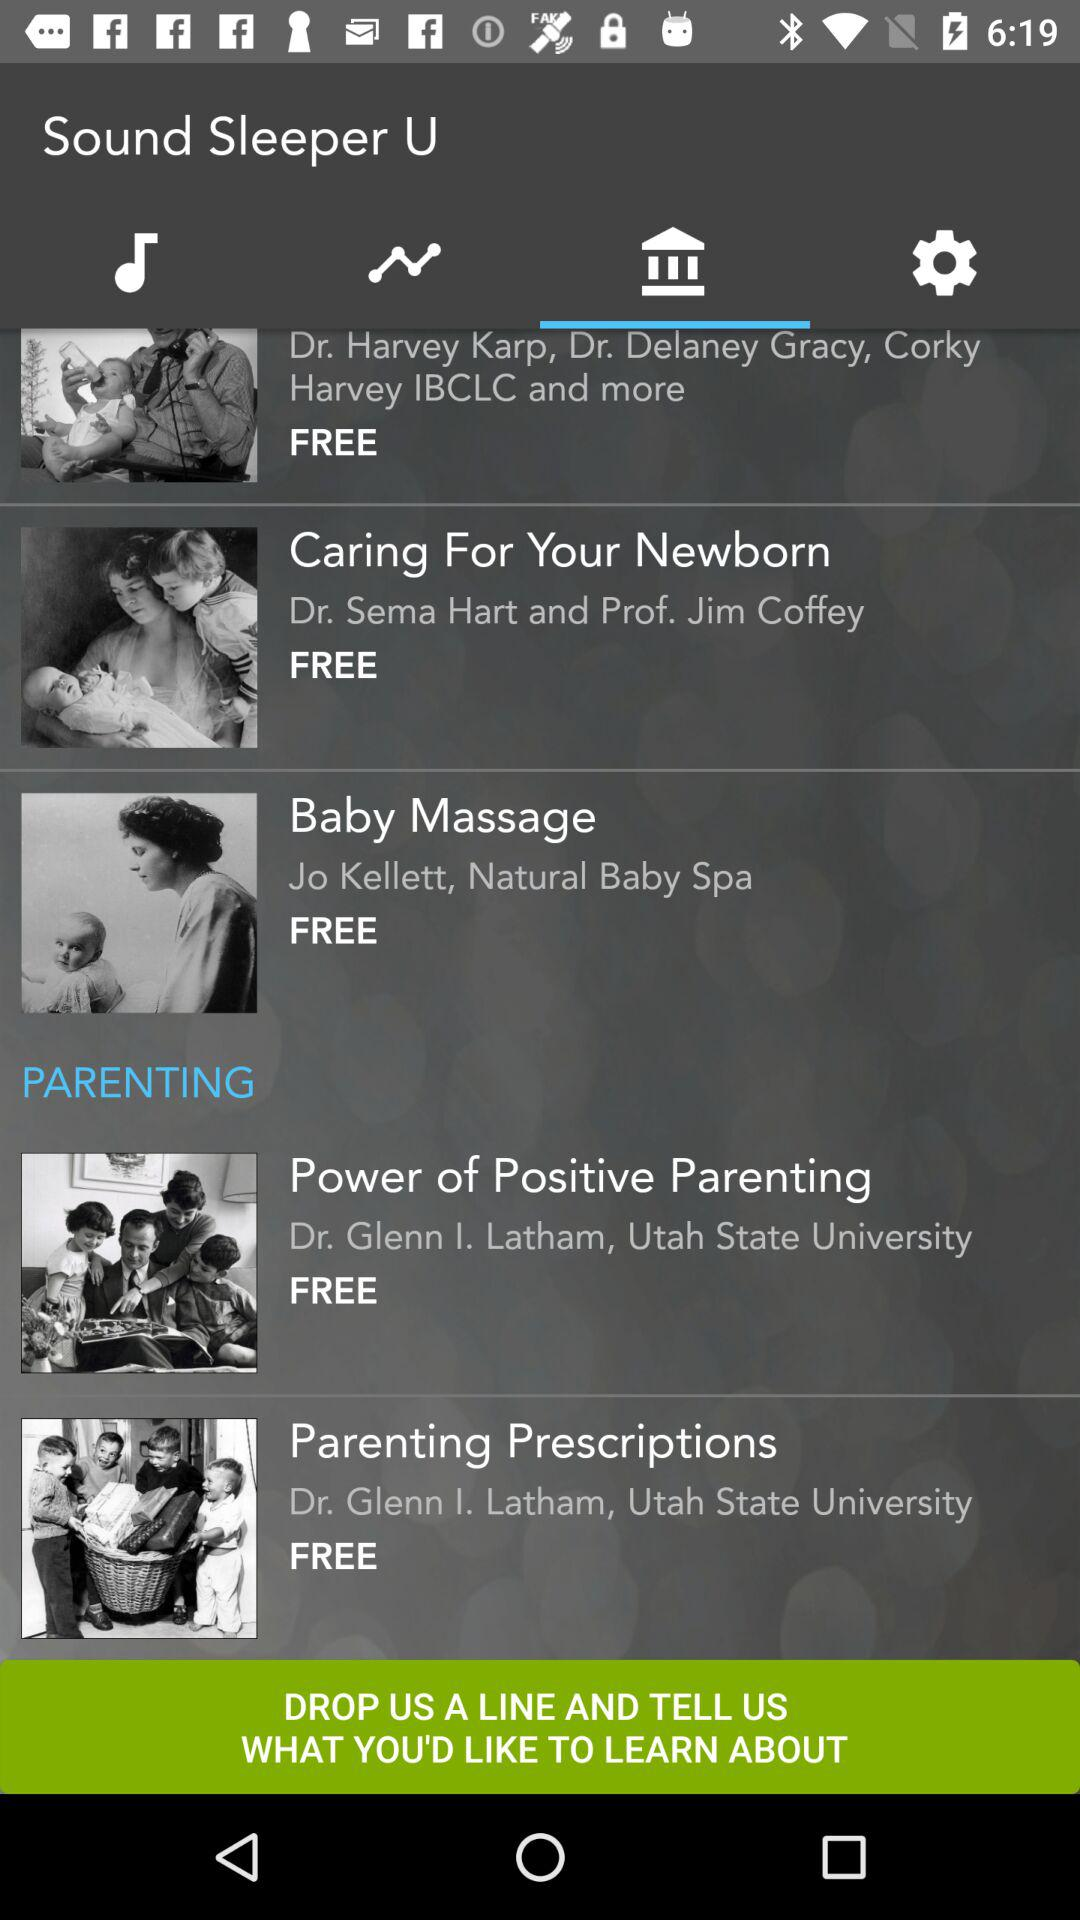Who is the author of "Caring For Your Newborn"? The authors are Dr. Sema Hart and Prof. Jim Coffey. 